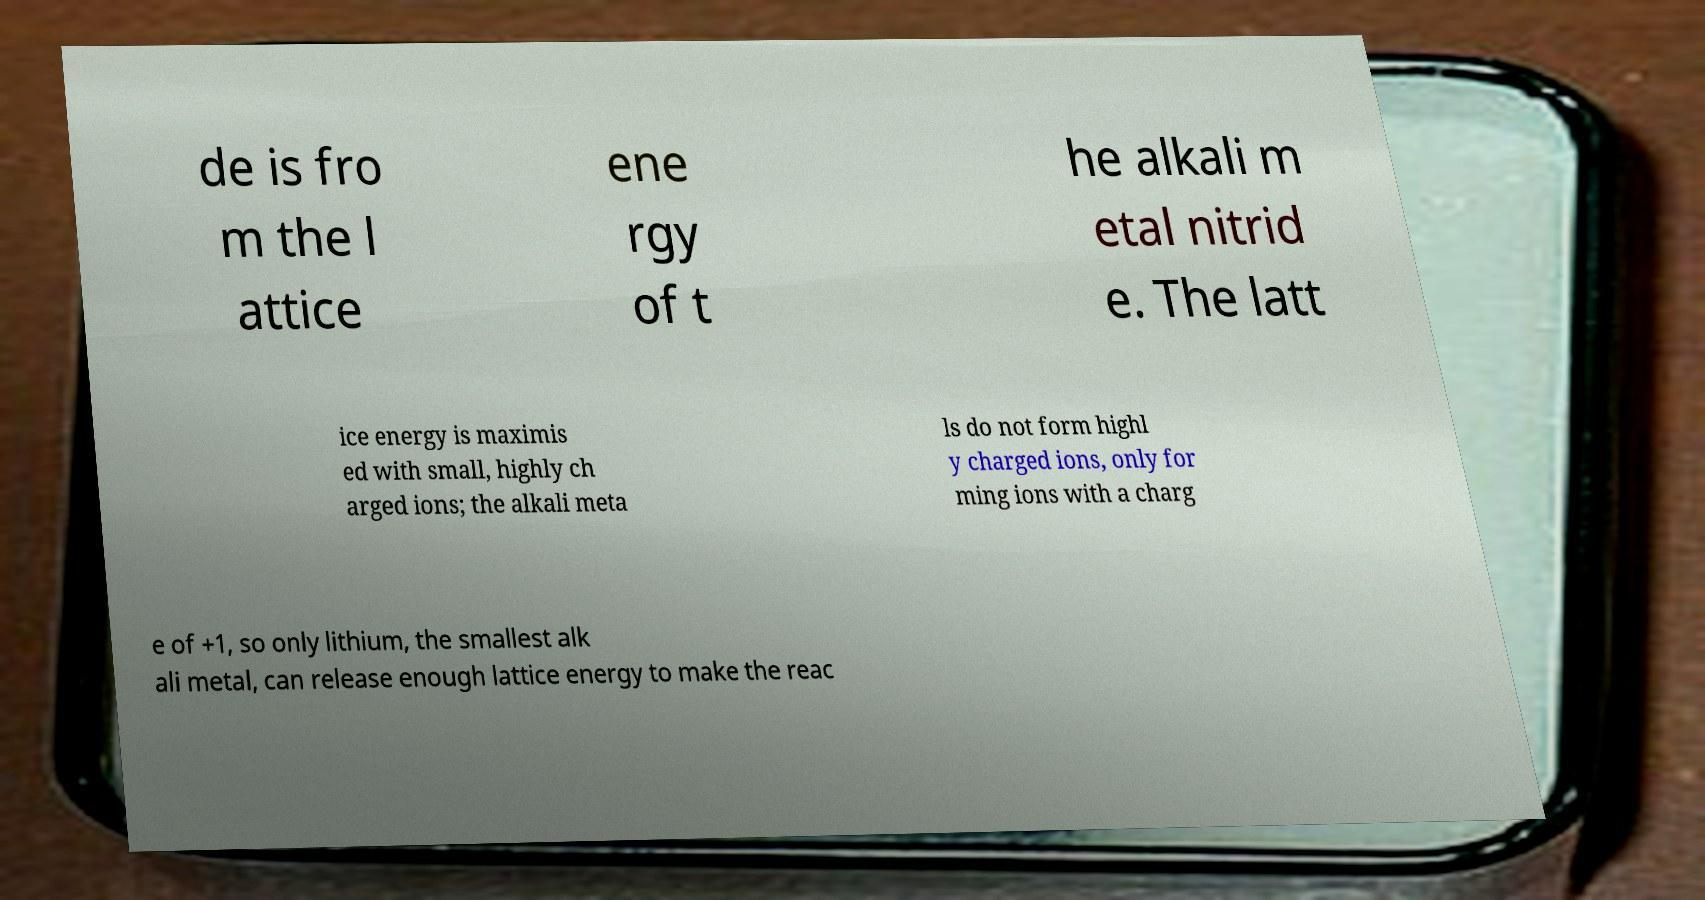I need the written content from this picture converted into text. Can you do that? de is fro m the l attice ene rgy of t he alkali m etal nitrid e. The latt ice energy is maximis ed with small, highly ch arged ions; the alkali meta ls do not form highl y charged ions, only for ming ions with a charg e of +1, so only lithium, the smallest alk ali metal, can release enough lattice energy to make the reac 